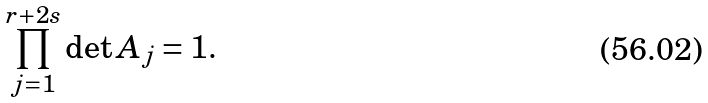Convert formula to latex. <formula><loc_0><loc_0><loc_500><loc_500>\prod _ { j = 1 } ^ { r + 2 s } \det A _ { j } = 1 .</formula> 